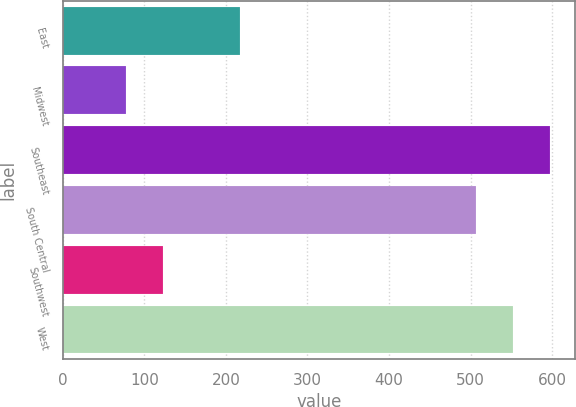Convert chart. <chart><loc_0><loc_0><loc_500><loc_500><bar_chart><fcel>East<fcel>Midwest<fcel>Southeast<fcel>South Central<fcel>Southwest<fcel>West<nl><fcel>217.3<fcel>77.5<fcel>597.8<fcel>506.1<fcel>123.35<fcel>551.95<nl></chart> 